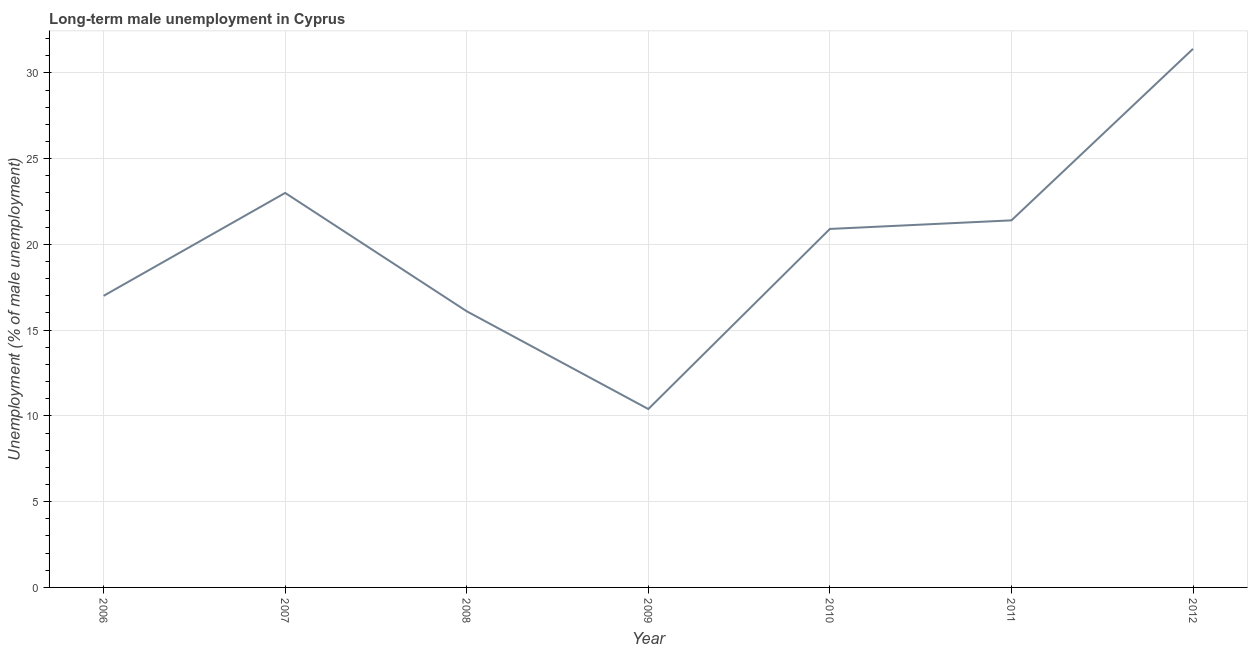What is the long-term male unemployment in 2010?
Offer a very short reply. 20.9. Across all years, what is the maximum long-term male unemployment?
Provide a succinct answer. 31.4. Across all years, what is the minimum long-term male unemployment?
Offer a terse response. 10.4. In which year was the long-term male unemployment minimum?
Provide a short and direct response. 2009. What is the sum of the long-term male unemployment?
Your answer should be very brief. 140.2. What is the difference between the long-term male unemployment in 2006 and 2012?
Keep it short and to the point. -14.4. What is the average long-term male unemployment per year?
Keep it short and to the point. 20.03. What is the median long-term male unemployment?
Offer a terse response. 20.9. Do a majority of the years between 2009 and 2012 (inclusive) have long-term male unemployment greater than 29 %?
Your response must be concise. No. What is the ratio of the long-term male unemployment in 2007 to that in 2011?
Make the answer very short. 1.07. Is the difference between the long-term male unemployment in 2008 and 2009 greater than the difference between any two years?
Your answer should be compact. No. What is the difference between the highest and the second highest long-term male unemployment?
Your response must be concise. 8.4. Is the sum of the long-term male unemployment in 2007 and 2010 greater than the maximum long-term male unemployment across all years?
Keep it short and to the point. Yes. What is the difference between the highest and the lowest long-term male unemployment?
Offer a terse response. 21. In how many years, is the long-term male unemployment greater than the average long-term male unemployment taken over all years?
Ensure brevity in your answer.  4. Does the long-term male unemployment monotonically increase over the years?
Your answer should be compact. No. How many lines are there?
Make the answer very short. 1. Are the values on the major ticks of Y-axis written in scientific E-notation?
Provide a succinct answer. No. Does the graph contain grids?
Make the answer very short. Yes. What is the title of the graph?
Keep it short and to the point. Long-term male unemployment in Cyprus. What is the label or title of the Y-axis?
Offer a very short reply. Unemployment (% of male unemployment). What is the Unemployment (% of male unemployment) of 2007?
Offer a terse response. 23. What is the Unemployment (% of male unemployment) in 2008?
Offer a terse response. 16.1. What is the Unemployment (% of male unemployment) in 2009?
Provide a short and direct response. 10.4. What is the Unemployment (% of male unemployment) of 2010?
Make the answer very short. 20.9. What is the Unemployment (% of male unemployment) of 2011?
Give a very brief answer. 21.4. What is the Unemployment (% of male unemployment) in 2012?
Make the answer very short. 31.4. What is the difference between the Unemployment (% of male unemployment) in 2006 and 2008?
Ensure brevity in your answer.  0.9. What is the difference between the Unemployment (% of male unemployment) in 2006 and 2010?
Offer a terse response. -3.9. What is the difference between the Unemployment (% of male unemployment) in 2006 and 2011?
Ensure brevity in your answer.  -4.4. What is the difference between the Unemployment (% of male unemployment) in 2006 and 2012?
Ensure brevity in your answer.  -14.4. What is the difference between the Unemployment (% of male unemployment) in 2007 and 2008?
Make the answer very short. 6.9. What is the difference between the Unemployment (% of male unemployment) in 2007 and 2010?
Provide a short and direct response. 2.1. What is the difference between the Unemployment (% of male unemployment) in 2007 and 2011?
Keep it short and to the point. 1.6. What is the difference between the Unemployment (% of male unemployment) in 2008 and 2009?
Provide a short and direct response. 5.7. What is the difference between the Unemployment (% of male unemployment) in 2008 and 2011?
Your answer should be compact. -5.3. What is the difference between the Unemployment (% of male unemployment) in 2008 and 2012?
Offer a very short reply. -15.3. What is the difference between the Unemployment (% of male unemployment) in 2009 and 2010?
Your answer should be compact. -10.5. What is the difference between the Unemployment (% of male unemployment) in 2009 and 2011?
Make the answer very short. -11. What is the difference between the Unemployment (% of male unemployment) in 2009 and 2012?
Ensure brevity in your answer.  -21. What is the difference between the Unemployment (% of male unemployment) in 2011 and 2012?
Your answer should be very brief. -10. What is the ratio of the Unemployment (% of male unemployment) in 2006 to that in 2007?
Provide a short and direct response. 0.74. What is the ratio of the Unemployment (% of male unemployment) in 2006 to that in 2008?
Your response must be concise. 1.06. What is the ratio of the Unemployment (% of male unemployment) in 2006 to that in 2009?
Offer a very short reply. 1.64. What is the ratio of the Unemployment (% of male unemployment) in 2006 to that in 2010?
Offer a very short reply. 0.81. What is the ratio of the Unemployment (% of male unemployment) in 2006 to that in 2011?
Offer a terse response. 0.79. What is the ratio of the Unemployment (% of male unemployment) in 2006 to that in 2012?
Give a very brief answer. 0.54. What is the ratio of the Unemployment (% of male unemployment) in 2007 to that in 2008?
Give a very brief answer. 1.43. What is the ratio of the Unemployment (% of male unemployment) in 2007 to that in 2009?
Your answer should be compact. 2.21. What is the ratio of the Unemployment (% of male unemployment) in 2007 to that in 2010?
Give a very brief answer. 1.1. What is the ratio of the Unemployment (% of male unemployment) in 2007 to that in 2011?
Offer a very short reply. 1.07. What is the ratio of the Unemployment (% of male unemployment) in 2007 to that in 2012?
Give a very brief answer. 0.73. What is the ratio of the Unemployment (% of male unemployment) in 2008 to that in 2009?
Offer a very short reply. 1.55. What is the ratio of the Unemployment (% of male unemployment) in 2008 to that in 2010?
Your response must be concise. 0.77. What is the ratio of the Unemployment (% of male unemployment) in 2008 to that in 2011?
Your answer should be compact. 0.75. What is the ratio of the Unemployment (% of male unemployment) in 2008 to that in 2012?
Your answer should be compact. 0.51. What is the ratio of the Unemployment (% of male unemployment) in 2009 to that in 2010?
Provide a succinct answer. 0.5. What is the ratio of the Unemployment (% of male unemployment) in 2009 to that in 2011?
Offer a very short reply. 0.49. What is the ratio of the Unemployment (% of male unemployment) in 2009 to that in 2012?
Your answer should be compact. 0.33. What is the ratio of the Unemployment (% of male unemployment) in 2010 to that in 2012?
Your answer should be compact. 0.67. What is the ratio of the Unemployment (% of male unemployment) in 2011 to that in 2012?
Offer a very short reply. 0.68. 